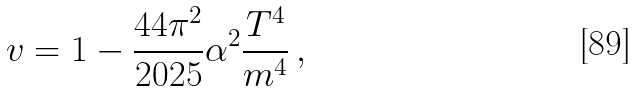Convert formula to latex. <formula><loc_0><loc_0><loc_500><loc_500>v = 1 - \frac { 4 4 \pi ^ { 2 } } { 2 0 2 5 } \alpha ^ { 2 } \frac { T ^ { 4 } } { m ^ { 4 } } \, ,</formula> 